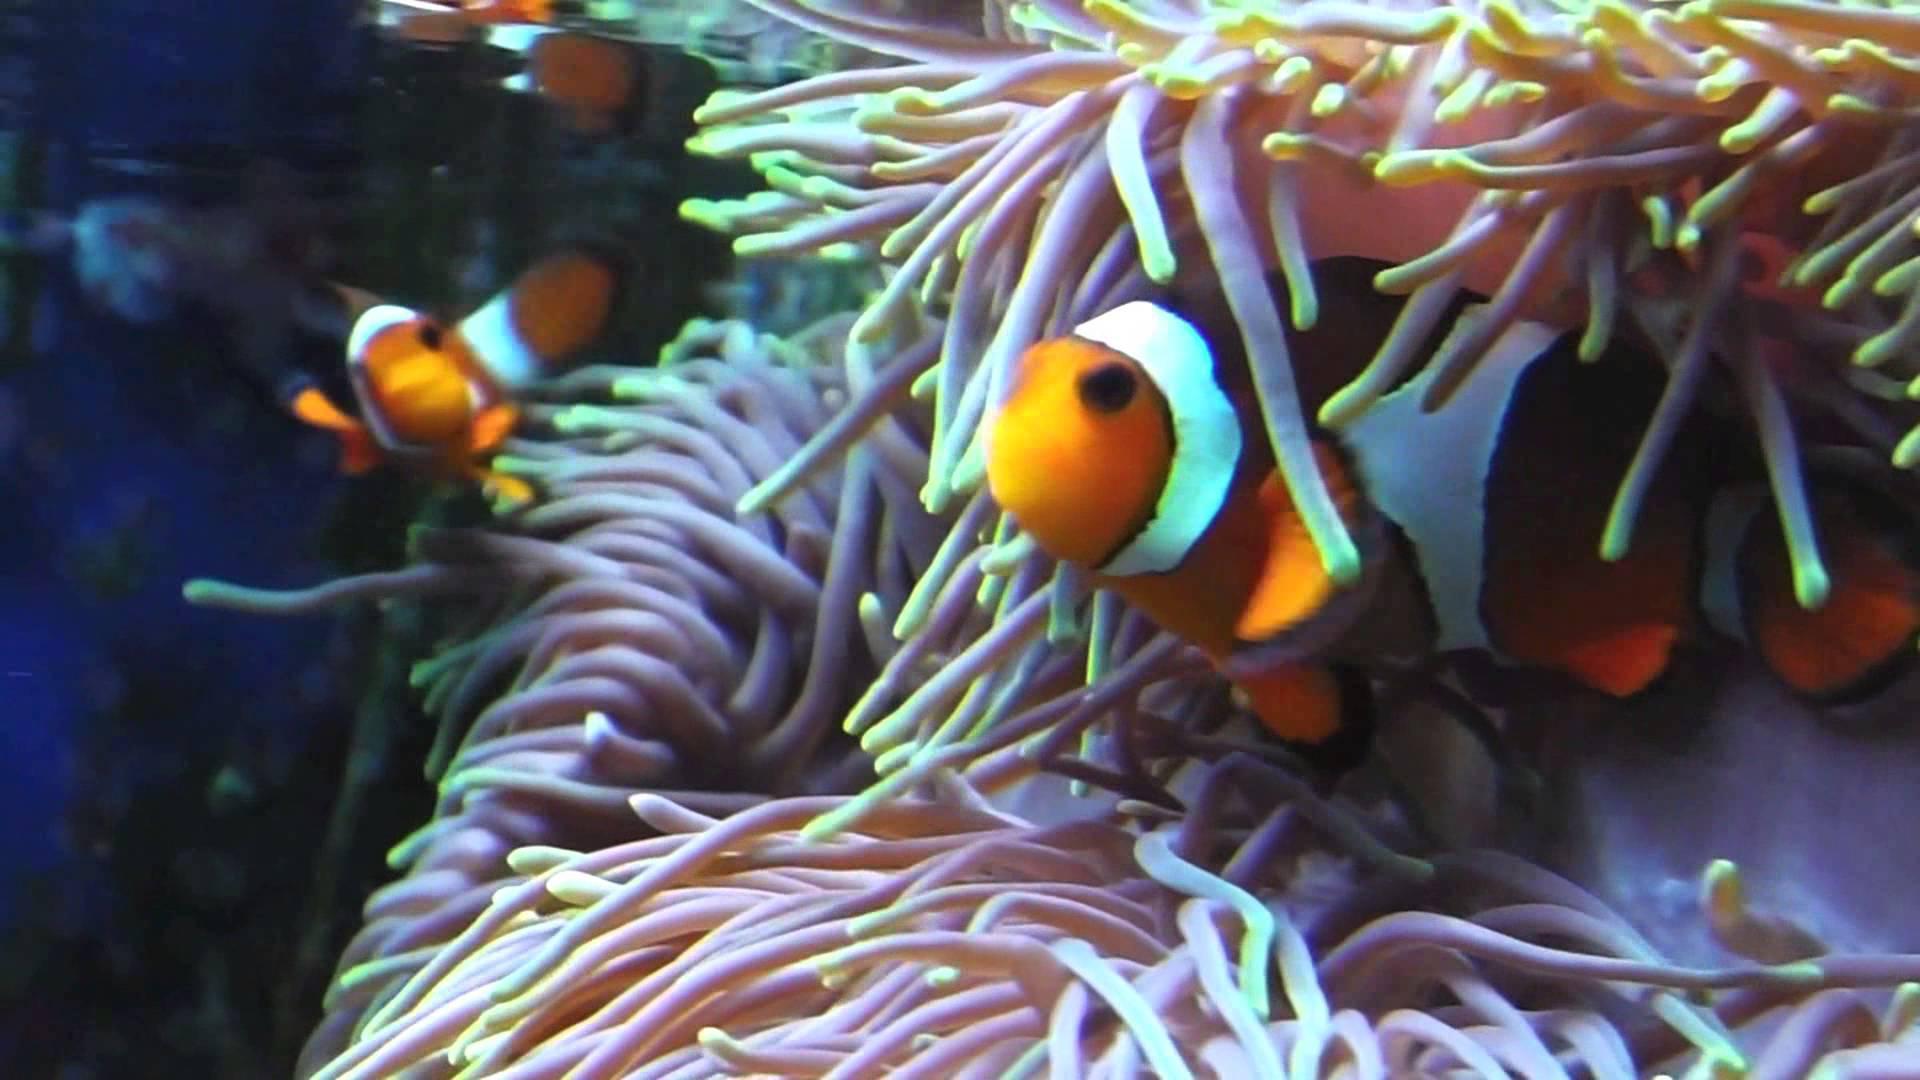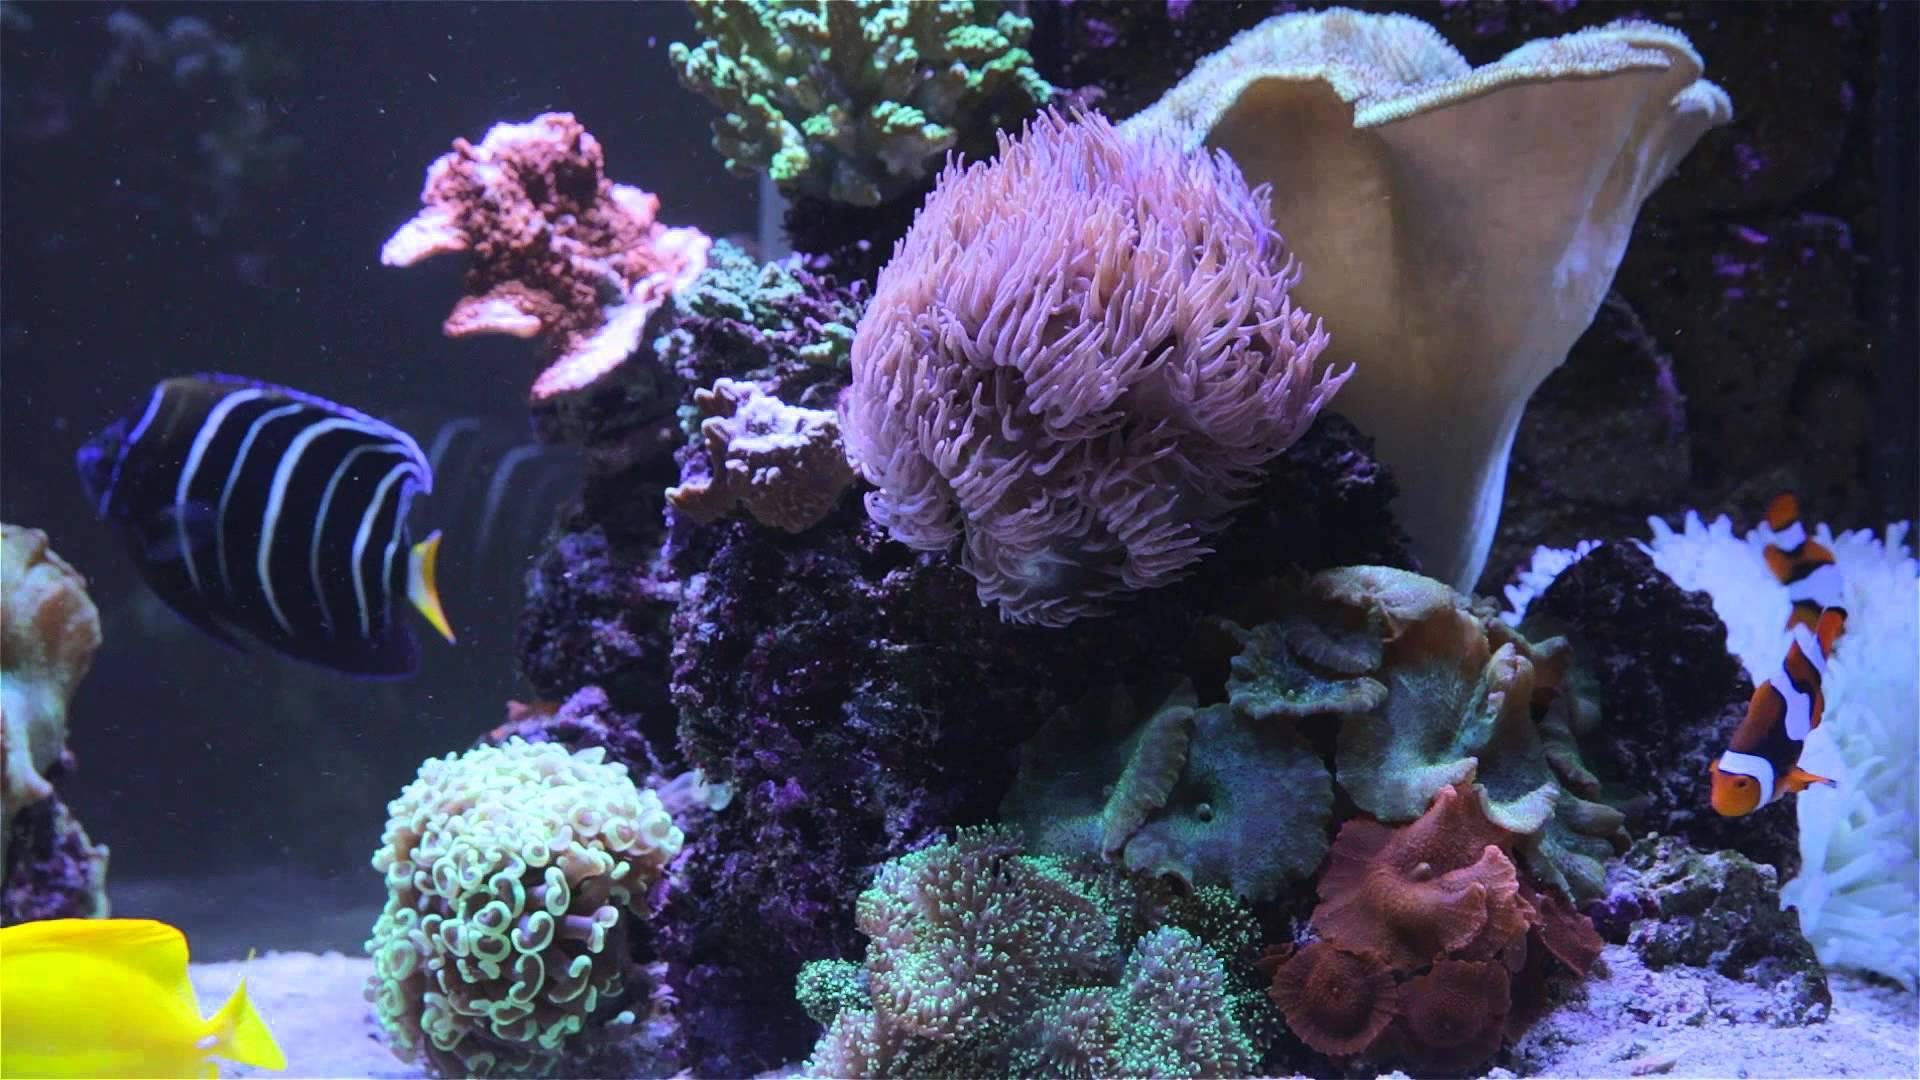The first image is the image on the left, the second image is the image on the right. For the images displayed, is the sentence "One image shows bright yellow-orange clown fish with white stripes in and near anemone tendrils with a pinkish hue." factually correct? Answer yes or no. Yes. The first image is the image on the left, the second image is the image on the right. For the images shown, is this caption "The clownfish in the left image is not actually within the anemone right now." true? Answer yes or no. No. 